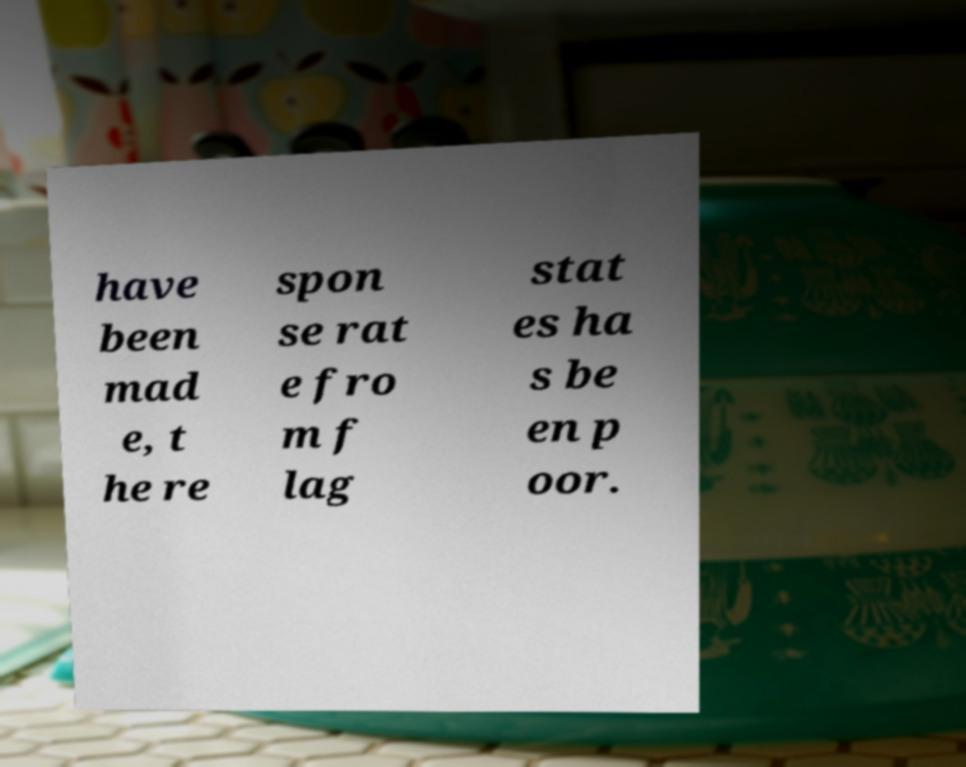Please read and relay the text visible in this image. What does it say? have been mad e, t he re spon se rat e fro m f lag stat es ha s be en p oor. 